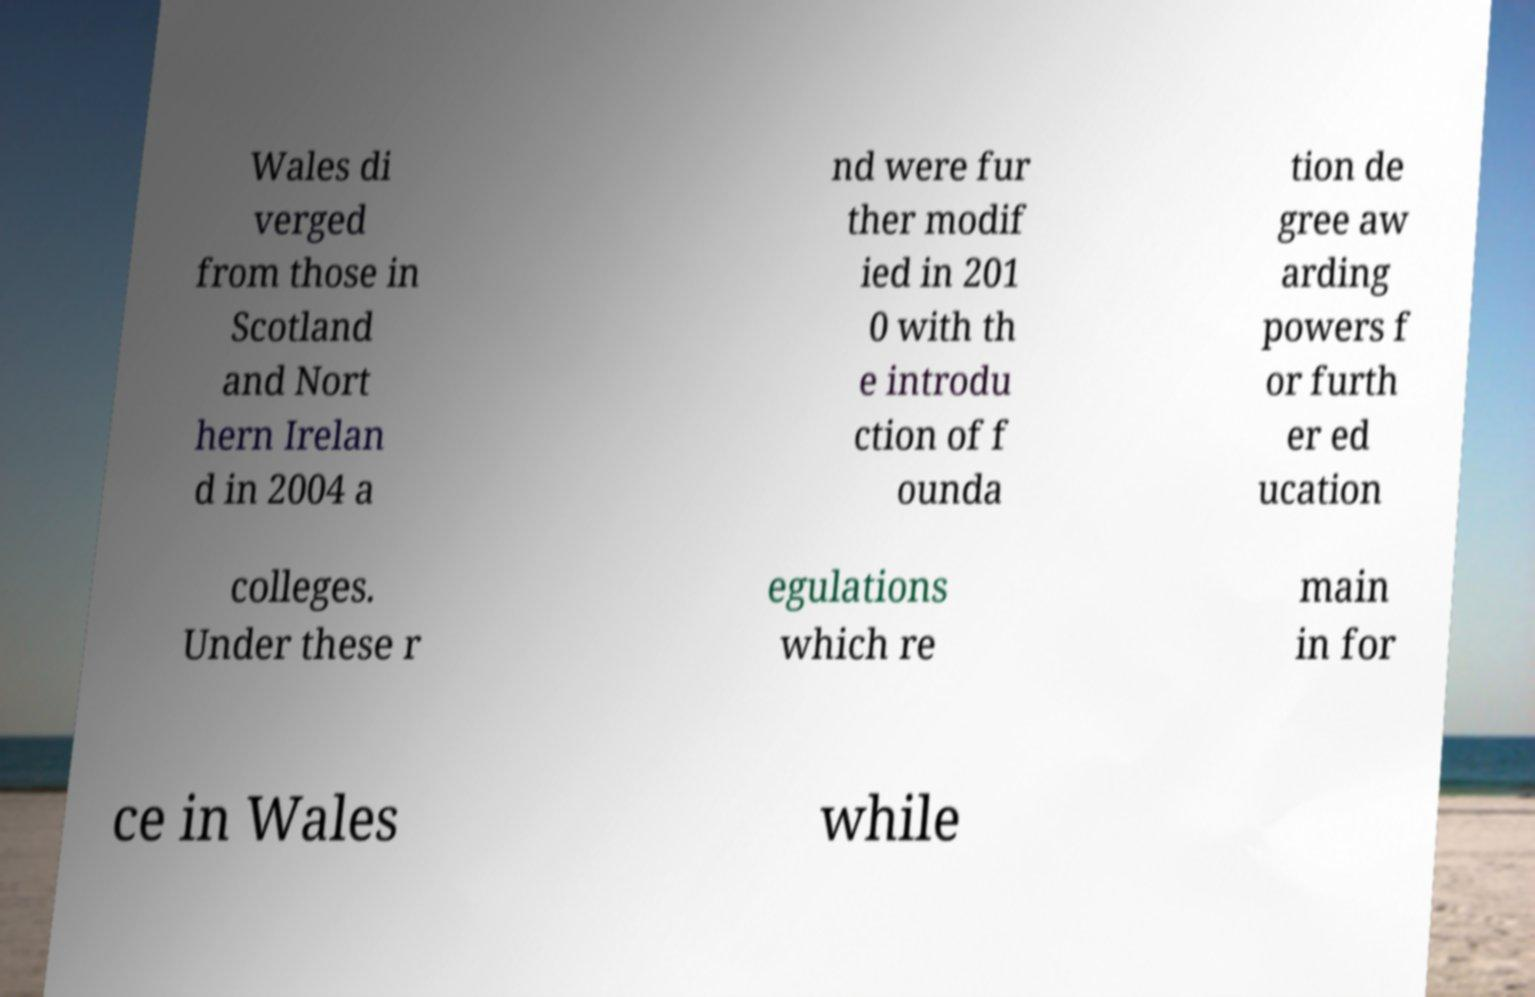Please identify and transcribe the text found in this image. Wales di verged from those in Scotland and Nort hern Irelan d in 2004 a nd were fur ther modif ied in 201 0 with th e introdu ction of f ounda tion de gree aw arding powers f or furth er ed ucation colleges. Under these r egulations which re main in for ce in Wales while 